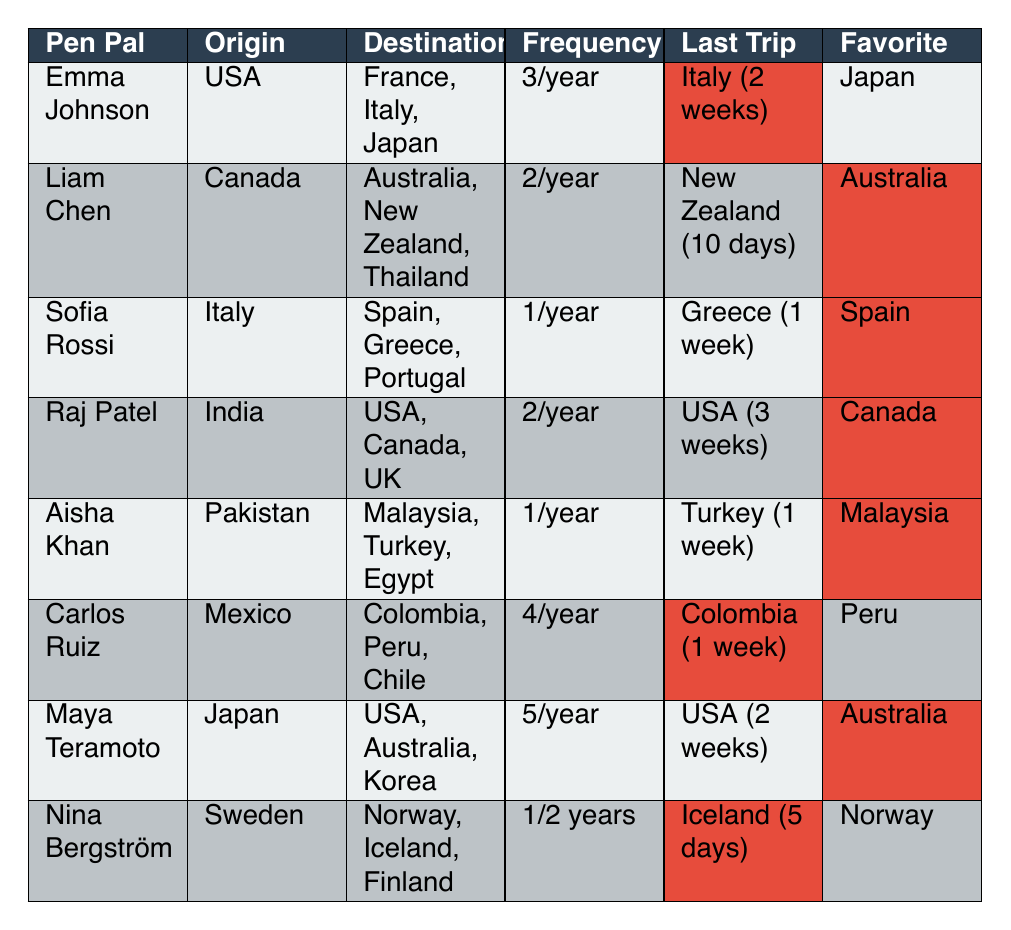What is the favorite destination of Raj Patel? Raj Patel's favorite destination is listed in the table under the "Favorite" column, which identifies "Canada" as his favorite.
Answer: Canada How many times a year does Maya Teramoto travel? The table states that Maya Teramoto travels 5 times a year, found in the "Frequency" column next to her name.
Answer: 5 times a year Which pen pal has traveled to the most countries? The number of destinations visited is found under the "Destinations" column. Maya Teramoto has visited 3 countries (USA, Australia, Korea), which is the highest along with others like Emma Johnson. Thus, multiple pen pals have traveled to 3 countries.
Answer: Emma Johnson and others Is Aisha Khan's last trip longer than a week? Aisha Khan's last trip is listed as Turkey (1 week) in the table. Since 1 week is not longer than a week, the statement is false.
Answer: No What is the average travel frequency of the pen pals? To calculate the average, we convert their frequencies into numerical values: Emma (3), Liam (2), Sofia (1), Raj (2), Aisha (1), Carlos (4), Maya (5), and Nina (0.5). The sum is 3 + 2 + 1 + 2 + 1 + 4 + 5 + 0.5 = 19.5 and there are 8 pen pals, so 19.5/8 = 2.4375 which can be rounded to 2.44 times a year.
Answer: Approximately 2.44 times a year Which pen pal travels the least frequently? Nina Bergström travels 1 time every two years, which is the lowest frequency in the table, as all others travel more frequently.
Answer: Nina Bergström How many pen pals have favorite destinations in Asia? The favorite destinations for the pen pals are: Japan (Emma), Australia (Liam and Maya), and Malaysia (Aisha), thus 4 pen pals have favorite destinations in Asia, Emma and Maya’s (Australia) are technically Asian regions too.
Answer: 4 Which countries has Carlos Ruiz visited? The "Destinations Visited" column indicates that Carlos Ruiz has been to Colombia, Peru, and Chile.
Answer: Colombia, Peru, Chile Who has the longest trip duration listed? Raj Patel's trip duration of 3 weeks is the longest against all others’ specified durations in the "Trip Duration" column.
Answer: Raj Patel 